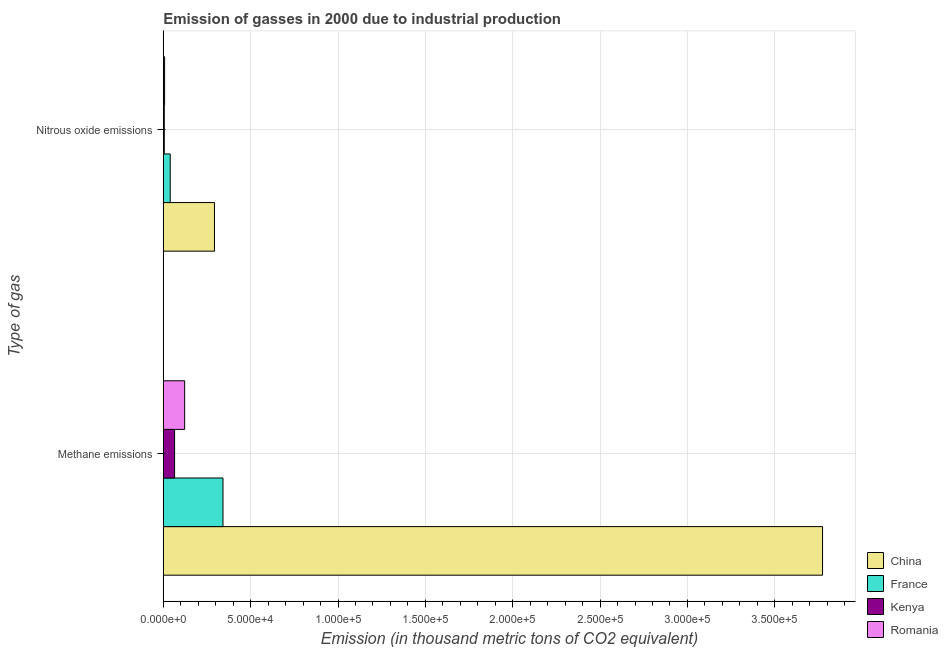How many groups of bars are there?
Offer a very short reply. 2. Are the number of bars per tick equal to the number of legend labels?
Make the answer very short. Yes. How many bars are there on the 1st tick from the top?
Ensure brevity in your answer.  4. How many bars are there on the 1st tick from the bottom?
Provide a short and direct response. 4. What is the label of the 1st group of bars from the top?
Your answer should be very brief. Nitrous oxide emissions. What is the amount of nitrous oxide emissions in Kenya?
Give a very brief answer. 551.5. Across all countries, what is the maximum amount of nitrous oxide emissions?
Offer a terse response. 2.93e+04. Across all countries, what is the minimum amount of methane emissions?
Your answer should be very brief. 6461.4. In which country was the amount of methane emissions minimum?
Your response must be concise. Kenya. What is the total amount of nitrous oxide emissions in the graph?
Give a very brief answer. 3.45e+04. What is the difference between the amount of methane emissions in Kenya and that in France?
Offer a terse response. -2.77e+04. What is the difference between the amount of nitrous oxide emissions in China and the amount of methane emissions in Kenya?
Your answer should be very brief. 2.28e+04. What is the average amount of nitrous oxide emissions per country?
Your answer should be compact. 8633.35. What is the difference between the amount of nitrous oxide emissions and amount of methane emissions in Kenya?
Provide a succinct answer. -5909.9. What is the ratio of the amount of methane emissions in France to that in China?
Your answer should be very brief. 0.09. Is the amount of nitrous oxide emissions in Kenya less than that in Romania?
Your response must be concise. Yes. In how many countries, is the amount of methane emissions greater than the average amount of methane emissions taken over all countries?
Provide a short and direct response. 1. What does the 3rd bar from the top in Nitrous oxide emissions represents?
Your answer should be compact. France. How many bars are there?
Ensure brevity in your answer.  8. How many countries are there in the graph?
Ensure brevity in your answer.  4. What is the difference between two consecutive major ticks on the X-axis?
Offer a terse response. 5.00e+04. Does the graph contain any zero values?
Provide a succinct answer. No. Does the graph contain grids?
Your answer should be compact. Yes. How many legend labels are there?
Your answer should be compact. 4. What is the title of the graph?
Your answer should be compact. Emission of gasses in 2000 due to industrial production. What is the label or title of the X-axis?
Your response must be concise. Emission (in thousand metric tons of CO2 equivalent). What is the label or title of the Y-axis?
Ensure brevity in your answer.  Type of gas. What is the Emission (in thousand metric tons of CO2 equivalent) of China in Methane emissions?
Offer a very short reply. 3.77e+05. What is the Emission (in thousand metric tons of CO2 equivalent) in France in Methane emissions?
Give a very brief answer. 3.42e+04. What is the Emission (in thousand metric tons of CO2 equivalent) in Kenya in Methane emissions?
Your answer should be compact. 6461.4. What is the Emission (in thousand metric tons of CO2 equivalent) of Romania in Methane emissions?
Provide a short and direct response. 1.22e+04. What is the Emission (in thousand metric tons of CO2 equivalent) in China in Nitrous oxide emissions?
Make the answer very short. 2.93e+04. What is the Emission (in thousand metric tons of CO2 equivalent) in France in Nitrous oxide emissions?
Keep it short and to the point. 3963. What is the Emission (in thousand metric tons of CO2 equivalent) in Kenya in Nitrous oxide emissions?
Your answer should be compact. 551.5. What is the Emission (in thousand metric tons of CO2 equivalent) of Romania in Nitrous oxide emissions?
Your response must be concise. 735.3. Across all Type of gas, what is the maximum Emission (in thousand metric tons of CO2 equivalent) in China?
Provide a succinct answer. 3.77e+05. Across all Type of gas, what is the maximum Emission (in thousand metric tons of CO2 equivalent) in France?
Keep it short and to the point. 3.42e+04. Across all Type of gas, what is the maximum Emission (in thousand metric tons of CO2 equivalent) in Kenya?
Ensure brevity in your answer.  6461.4. Across all Type of gas, what is the maximum Emission (in thousand metric tons of CO2 equivalent) of Romania?
Provide a short and direct response. 1.22e+04. Across all Type of gas, what is the minimum Emission (in thousand metric tons of CO2 equivalent) of China?
Give a very brief answer. 2.93e+04. Across all Type of gas, what is the minimum Emission (in thousand metric tons of CO2 equivalent) of France?
Offer a very short reply. 3963. Across all Type of gas, what is the minimum Emission (in thousand metric tons of CO2 equivalent) in Kenya?
Your answer should be very brief. 551.5. Across all Type of gas, what is the minimum Emission (in thousand metric tons of CO2 equivalent) of Romania?
Ensure brevity in your answer.  735.3. What is the total Emission (in thousand metric tons of CO2 equivalent) of China in the graph?
Keep it short and to the point. 4.07e+05. What is the total Emission (in thousand metric tons of CO2 equivalent) in France in the graph?
Provide a short and direct response. 3.81e+04. What is the total Emission (in thousand metric tons of CO2 equivalent) of Kenya in the graph?
Your answer should be very brief. 7012.9. What is the total Emission (in thousand metric tons of CO2 equivalent) of Romania in the graph?
Keep it short and to the point. 1.30e+04. What is the difference between the Emission (in thousand metric tons of CO2 equivalent) in China in Methane emissions and that in Nitrous oxide emissions?
Provide a succinct answer. 3.48e+05. What is the difference between the Emission (in thousand metric tons of CO2 equivalent) in France in Methane emissions and that in Nitrous oxide emissions?
Offer a terse response. 3.02e+04. What is the difference between the Emission (in thousand metric tons of CO2 equivalent) in Kenya in Methane emissions and that in Nitrous oxide emissions?
Ensure brevity in your answer.  5909.9. What is the difference between the Emission (in thousand metric tons of CO2 equivalent) of Romania in Methane emissions and that in Nitrous oxide emissions?
Offer a very short reply. 1.15e+04. What is the difference between the Emission (in thousand metric tons of CO2 equivalent) of China in Methane emissions and the Emission (in thousand metric tons of CO2 equivalent) of France in Nitrous oxide emissions?
Your response must be concise. 3.73e+05. What is the difference between the Emission (in thousand metric tons of CO2 equivalent) in China in Methane emissions and the Emission (in thousand metric tons of CO2 equivalent) in Kenya in Nitrous oxide emissions?
Offer a very short reply. 3.77e+05. What is the difference between the Emission (in thousand metric tons of CO2 equivalent) of China in Methane emissions and the Emission (in thousand metric tons of CO2 equivalent) of Romania in Nitrous oxide emissions?
Your answer should be compact. 3.77e+05. What is the difference between the Emission (in thousand metric tons of CO2 equivalent) of France in Methane emissions and the Emission (in thousand metric tons of CO2 equivalent) of Kenya in Nitrous oxide emissions?
Offer a very short reply. 3.36e+04. What is the difference between the Emission (in thousand metric tons of CO2 equivalent) in France in Methane emissions and the Emission (in thousand metric tons of CO2 equivalent) in Romania in Nitrous oxide emissions?
Your answer should be very brief. 3.34e+04. What is the difference between the Emission (in thousand metric tons of CO2 equivalent) in Kenya in Methane emissions and the Emission (in thousand metric tons of CO2 equivalent) in Romania in Nitrous oxide emissions?
Keep it short and to the point. 5726.1. What is the average Emission (in thousand metric tons of CO2 equivalent) of China per Type of gas?
Provide a succinct answer. 2.03e+05. What is the average Emission (in thousand metric tons of CO2 equivalent) of France per Type of gas?
Your response must be concise. 1.91e+04. What is the average Emission (in thousand metric tons of CO2 equivalent) of Kenya per Type of gas?
Make the answer very short. 3506.45. What is the average Emission (in thousand metric tons of CO2 equivalent) in Romania per Type of gas?
Ensure brevity in your answer.  6477.15. What is the difference between the Emission (in thousand metric tons of CO2 equivalent) in China and Emission (in thousand metric tons of CO2 equivalent) in France in Methane emissions?
Provide a short and direct response. 3.43e+05. What is the difference between the Emission (in thousand metric tons of CO2 equivalent) of China and Emission (in thousand metric tons of CO2 equivalent) of Kenya in Methane emissions?
Your answer should be very brief. 3.71e+05. What is the difference between the Emission (in thousand metric tons of CO2 equivalent) of China and Emission (in thousand metric tons of CO2 equivalent) of Romania in Methane emissions?
Keep it short and to the point. 3.65e+05. What is the difference between the Emission (in thousand metric tons of CO2 equivalent) in France and Emission (in thousand metric tons of CO2 equivalent) in Kenya in Methane emissions?
Your response must be concise. 2.77e+04. What is the difference between the Emission (in thousand metric tons of CO2 equivalent) of France and Emission (in thousand metric tons of CO2 equivalent) of Romania in Methane emissions?
Offer a terse response. 2.19e+04. What is the difference between the Emission (in thousand metric tons of CO2 equivalent) in Kenya and Emission (in thousand metric tons of CO2 equivalent) in Romania in Methane emissions?
Keep it short and to the point. -5757.6. What is the difference between the Emission (in thousand metric tons of CO2 equivalent) of China and Emission (in thousand metric tons of CO2 equivalent) of France in Nitrous oxide emissions?
Your answer should be very brief. 2.53e+04. What is the difference between the Emission (in thousand metric tons of CO2 equivalent) of China and Emission (in thousand metric tons of CO2 equivalent) of Kenya in Nitrous oxide emissions?
Make the answer very short. 2.87e+04. What is the difference between the Emission (in thousand metric tons of CO2 equivalent) of China and Emission (in thousand metric tons of CO2 equivalent) of Romania in Nitrous oxide emissions?
Offer a very short reply. 2.85e+04. What is the difference between the Emission (in thousand metric tons of CO2 equivalent) in France and Emission (in thousand metric tons of CO2 equivalent) in Kenya in Nitrous oxide emissions?
Your answer should be very brief. 3411.5. What is the difference between the Emission (in thousand metric tons of CO2 equivalent) in France and Emission (in thousand metric tons of CO2 equivalent) in Romania in Nitrous oxide emissions?
Make the answer very short. 3227.7. What is the difference between the Emission (in thousand metric tons of CO2 equivalent) of Kenya and Emission (in thousand metric tons of CO2 equivalent) of Romania in Nitrous oxide emissions?
Keep it short and to the point. -183.8. What is the ratio of the Emission (in thousand metric tons of CO2 equivalent) in China in Methane emissions to that in Nitrous oxide emissions?
Provide a succinct answer. 12.89. What is the ratio of the Emission (in thousand metric tons of CO2 equivalent) in France in Methane emissions to that in Nitrous oxide emissions?
Provide a short and direct response. 8.62. What is the ratio of the Emission (in thousand metric tons of CO2 equivalent) in Kenya in Methane emissions to that in Nitrous oxide emissions?
Your response must be concise. 11.72. What is the ratio of the Emission (in thousand metric tons of CO2 equivalent) of Romania in Methane emissions to that in Nitrous oxide emissions?
Provide a succinct answer. 16.62. What is the difference between the highest and the second highest Emission (in thousand metric tons of CO2 equivalent) in China?
Offer a terse response. 3.48e+05. What is the difference between the highest and the second highest Emission (in thousand metric tons of CO2 equivalent) in France?
Your answer should be compact. 3.02e+04. What is the difference between the highest and the second highest Emission (in thousand metric tons of CO2 equivalent) of Kenya?
Keep it short and to the point. 5909.9. What is the difference between the highest and the second highest Emission (in thousand metric tons of CO2 equivalent) of Romania?
Offer a terse response. 1.15e+04. What is the difference between the highest and the lowest Emission (in thousand metric tons of CO2 equivalent) of China?
Make the answer very short. 3.48e+05. What is the difference between the highest and the lowest Emission (in thousand metric tons of CO2 equivalent) in France?
Make the answer very short. 3.02e+04. What is the difference between the highest and the lowest Emission (in thousand metric tons of CO2 equivalent) in Kenya?
Your answer should be very brief. 5909.9. What is the difference between the highest and the lowest Emission (in thousand metric tons of CO2 equivalent) of Romania?
Provide a short and direct response. 1.15e+04. 